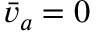<formula> <loc_0><loc_0><loc_500><loc_500>\bar { v } _ { a } = 0</formula> 